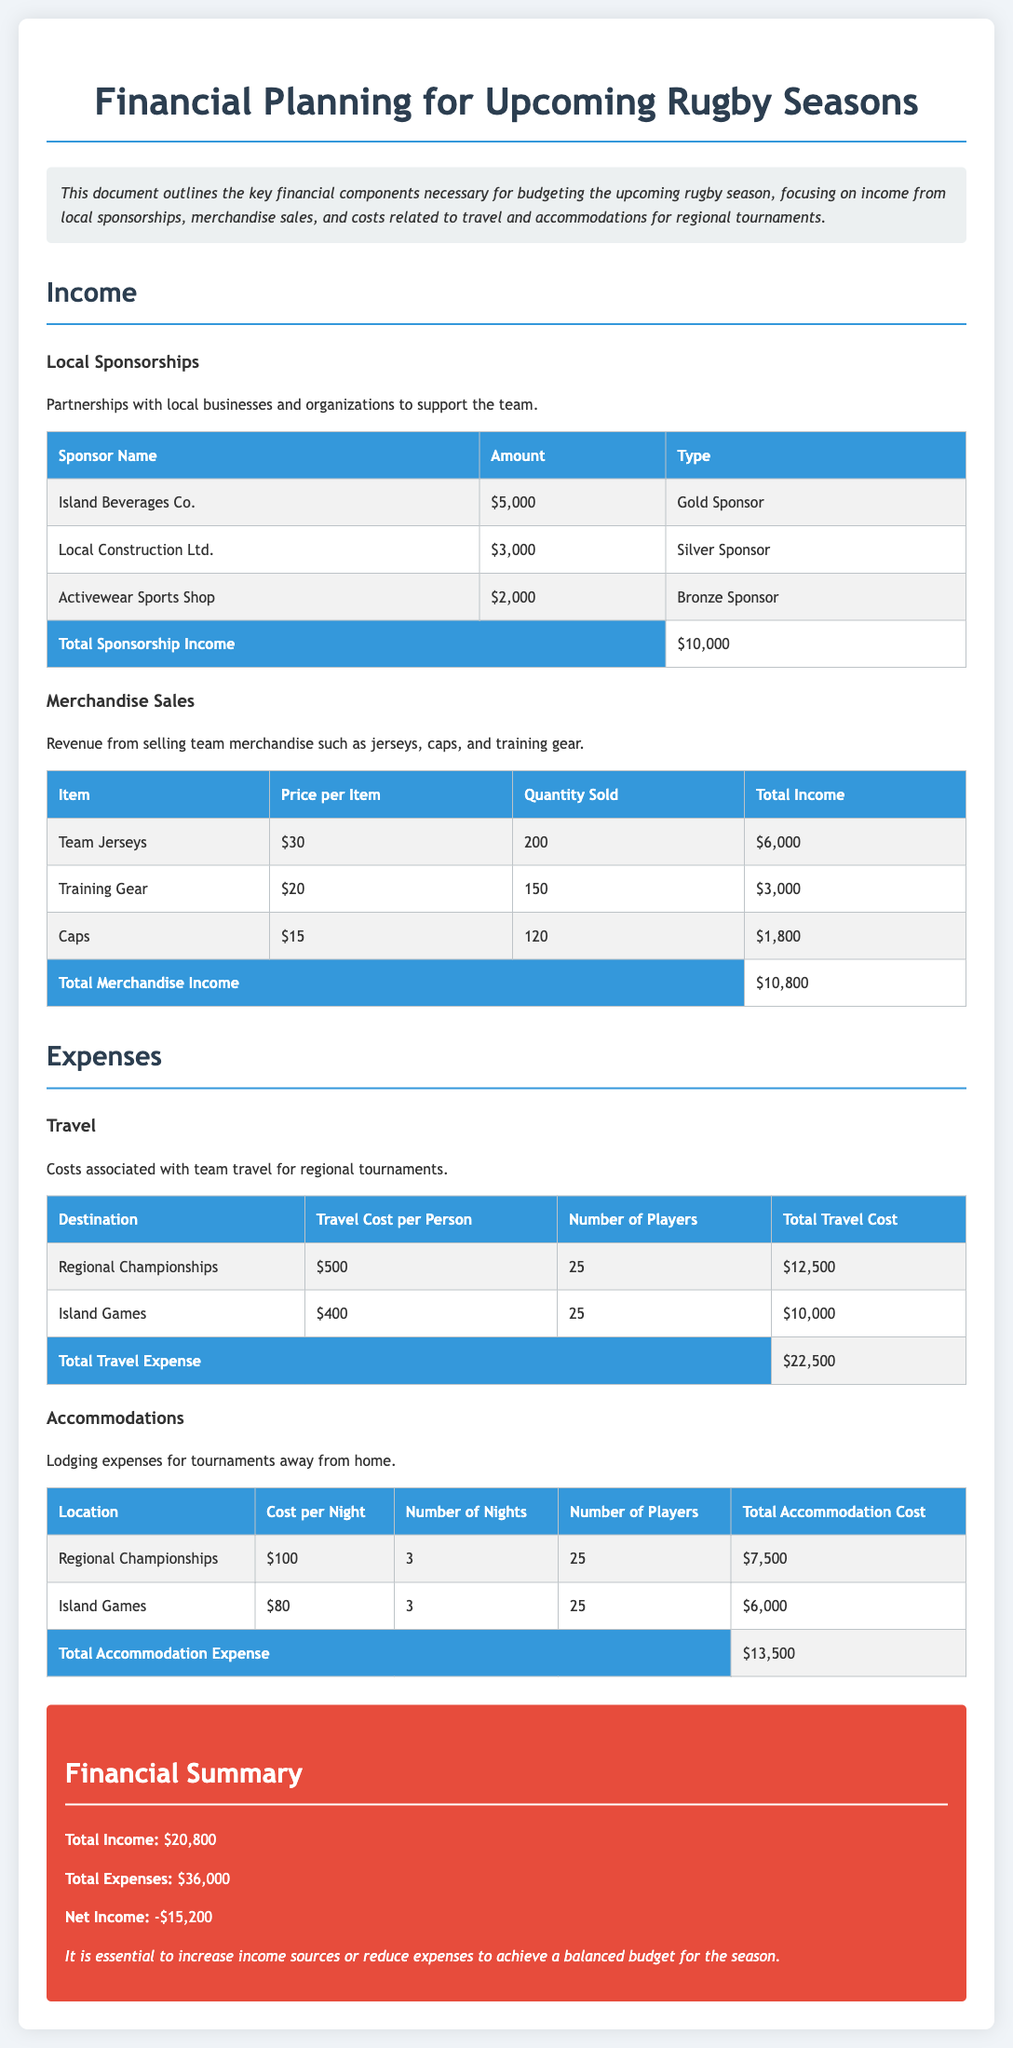what is the total sponsorship income? The total sponsorship income is calculated from the sum of individual sponsorship amounts listed in the document, which is $5,000 + $3,000 + $2,000.
Answer: $10,000 what is the total merchandise income? The total merchandise income is the sum of individual merchandise sales listed in the document, which is $6,000 + $3,000 + $1,800.
Answer: $10,800 what are the travel costs for the Regional Championships? The travel cost for the Regional Championships is stated as $500 per person for 25 players, which calculates to $12,500.
Answer: $12,500 what is the number of players traveling for the Island Games? The document states that there are 25 players traveling for the Island Games.
Answer: 25 what is the total accommodation expense? The total accommodation expense is calculated by adding the costs associated with the Regional Championships and the Island Games, which totals $7,500 + $6,000.
Answer: $13,500 what is the total income? The total income is derived from the total sponsorship and merchandise income combined, which totals $10,000 + $10,800.
Answer: $20,800 what is the net income for the upcoming season? The net income is the difference between total income and total expenses detailed in the document, which is $20,800 - $36,000.
Answer: -$15,200 what actions can be taken to achieve a balanced budget? A note in the document suggests increasing income sources or reducing expenses to achieve a balanced budget.
Answer: Increase income sources or reduce expenses what is the cost per night for accommodations at the Regional Championships? The cost per night for accommodations at the Regional Championships is listed as $100.
Answer: $100 what type of income is derived from local sponsorships? The document describes local sponsorships as income from partnerships with local businesses supporting the team.
Answer: Partnerships with local businesses 